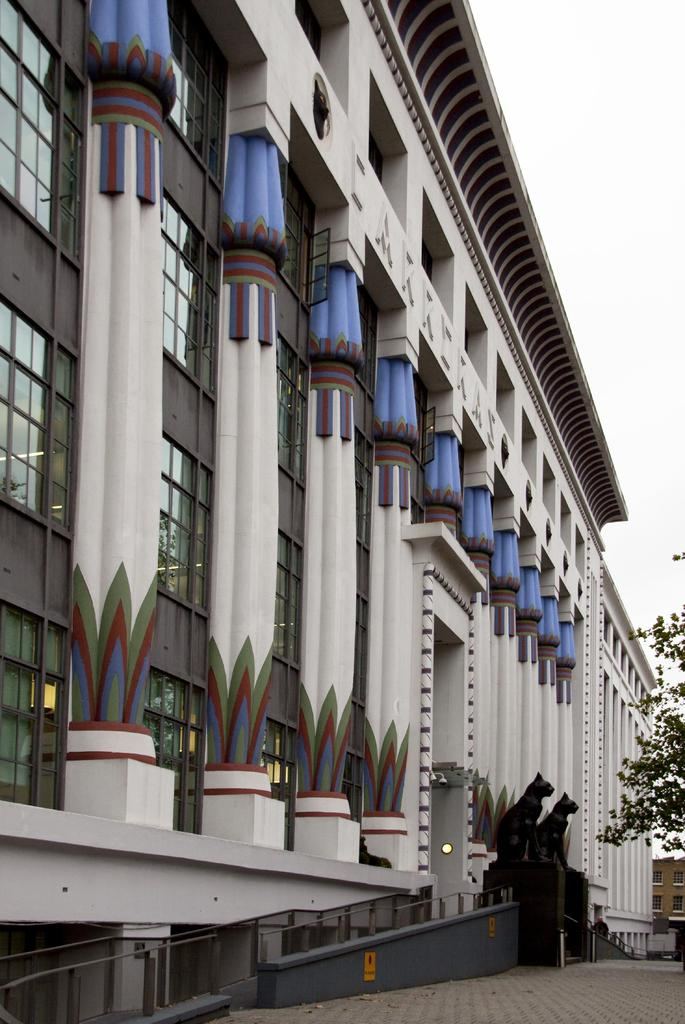What type of structure is present in the image? There is a building in the image. What artistic elements can be seen in the image? There are sculptures in the image. What type of vegetation is on the right side of the image? There is a tree on the right side of the image. What can be seen in the background of the image? The sky is visible in the background of the image. What type of cream is being used to improve the acoustics in the building? There is no mention of cream or acoustics in the image; it only features a building, sculptures, a tree, and the sky. 